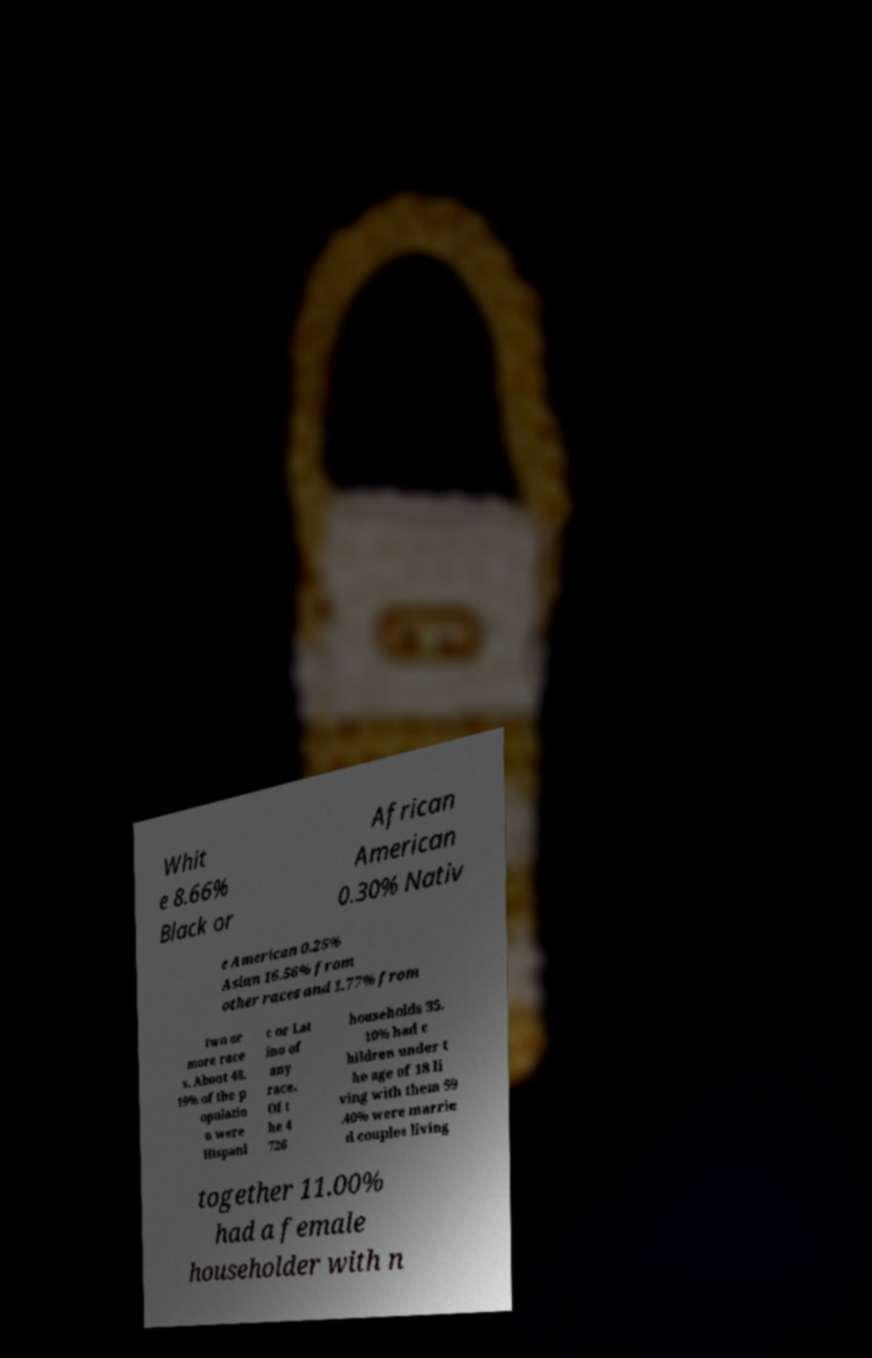Can you read and provide the text displayed in the image?This photo seems to have some interesting text. Can you extract and type it out for me? Whit e 8.66% Black or African American 0.30% Nativ e American 0.25% Asian 16.56% from other races and 1.77% from two or more race s. About 48. 19% of the p opulatio n were Hispani c or Lat ino of any race. Of t he 4 726 households 35. 10% had c hildren under t he age of 18 li ving with them 59 .40% were marrie d couples living together 11.00% had a female householder with n 